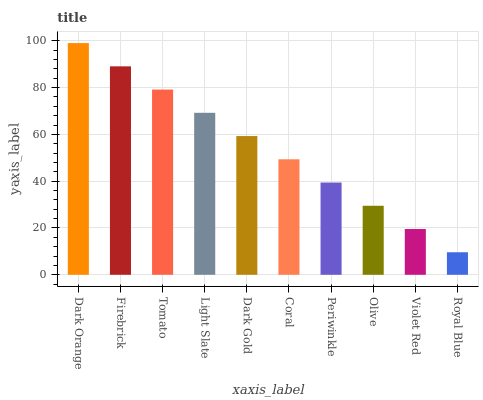Is Royal Blue the minimum?
Answer yes or no. Yes. Is Dark Orange the maximum?
Answer yes or no. Yes. Is Firebrick the minimum?
Answer yes or no. No. Is Firebrick the maximum?
Answer yes or no. No. Is Dark Orange greater than Firebrick?
Answer yes or no. Yes. Is Firebrick less than Dark Orange?
Answer yes or no. Yes. Is Firebrick greater than Dark Orange?
Answer yes or no. No. Is Dark Orange less than Firebrick?
Answer yes or no. No. Is Dark Gold the high median?
Answer yes or no. Yes. Is Coral the low median?
Answer yes or no. Yes. Is Light Slate the high median?
Answer yes or no. No. Is Firebrick the low median?
Answer yes or no. No. 